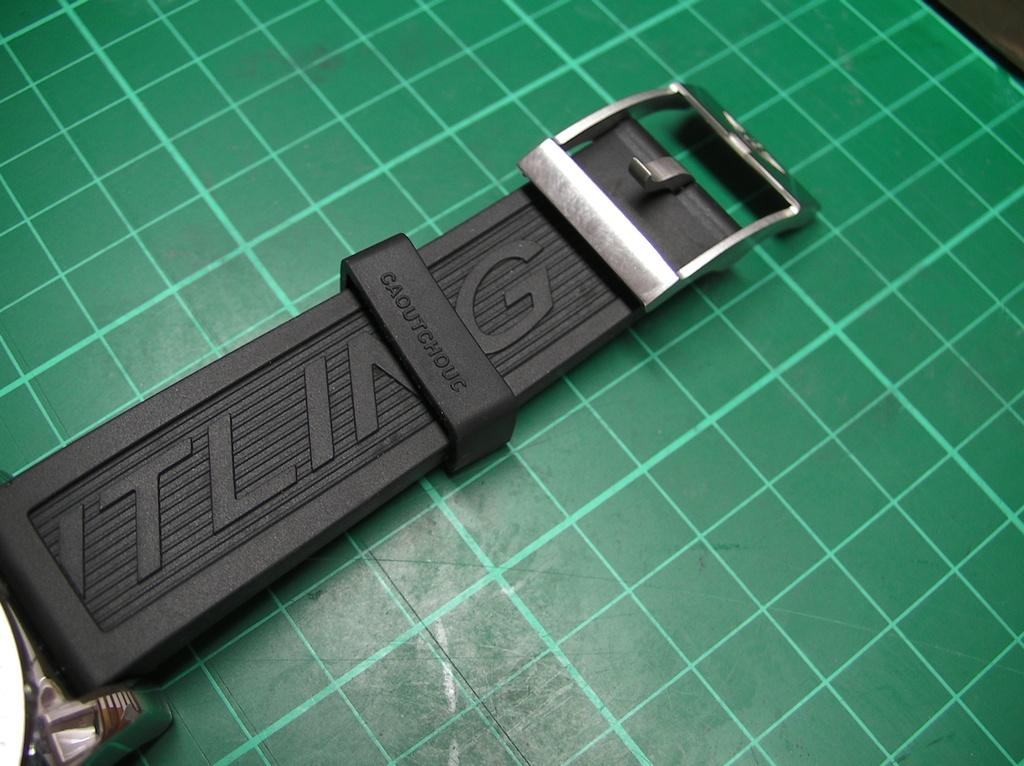<image>
Write a terse but informative summary of the picture. Black strap for a watch which says TLING on it. 